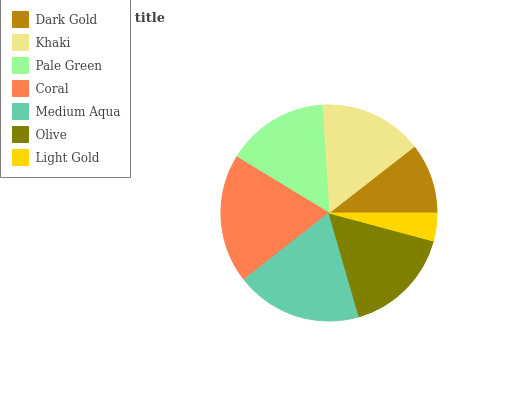Is Light Gold the minimum?
Answer yes or no. Yes. Is Coral the maximum?
Answer yes or no. Yes. Is Khaki the minimum?
Answer yes or no. No. Is Khaki the maximum?
Answer yes or no. No. Is Khaki greater than Dark Gold?
Answer yes or no. Yes. Is Dark Gold less than Khaki?
Answer yes or no. Yes. Is Dark Gold greater than Khaki?
Answer yes or no. No. Is Khaki less than Dark Gold?
Answer yes or no. No. Is Khaki the high median?
Answer yes or no. Yes. Is Khaki the low median?
Answer yes or no. Yes. Is Coral the high median?
Answer yes or no. No. Is Medium Aqua the low median?
Answer yes or no. No. 